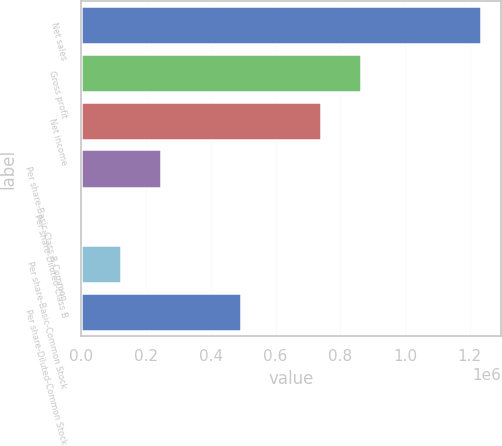Convert chart. <chart><loc_0><loc_0><loc_500><loc_500><bar_chart><fcel>Net sales<fcel>Gross profit<fcel>Net income<fcel>Per share-Basic-Class B Common<fcel>Per share-Diluted-Class B<fcel>Per share-Basic-Common Stock<fcel>Per share-Diluted-Common Stock<nl><fcel>1.23603e+06<fcel>865222<fcel>741619<fcel>247206<fcel>0.26<fcel>123603<fcel>494413<nl></chart> 